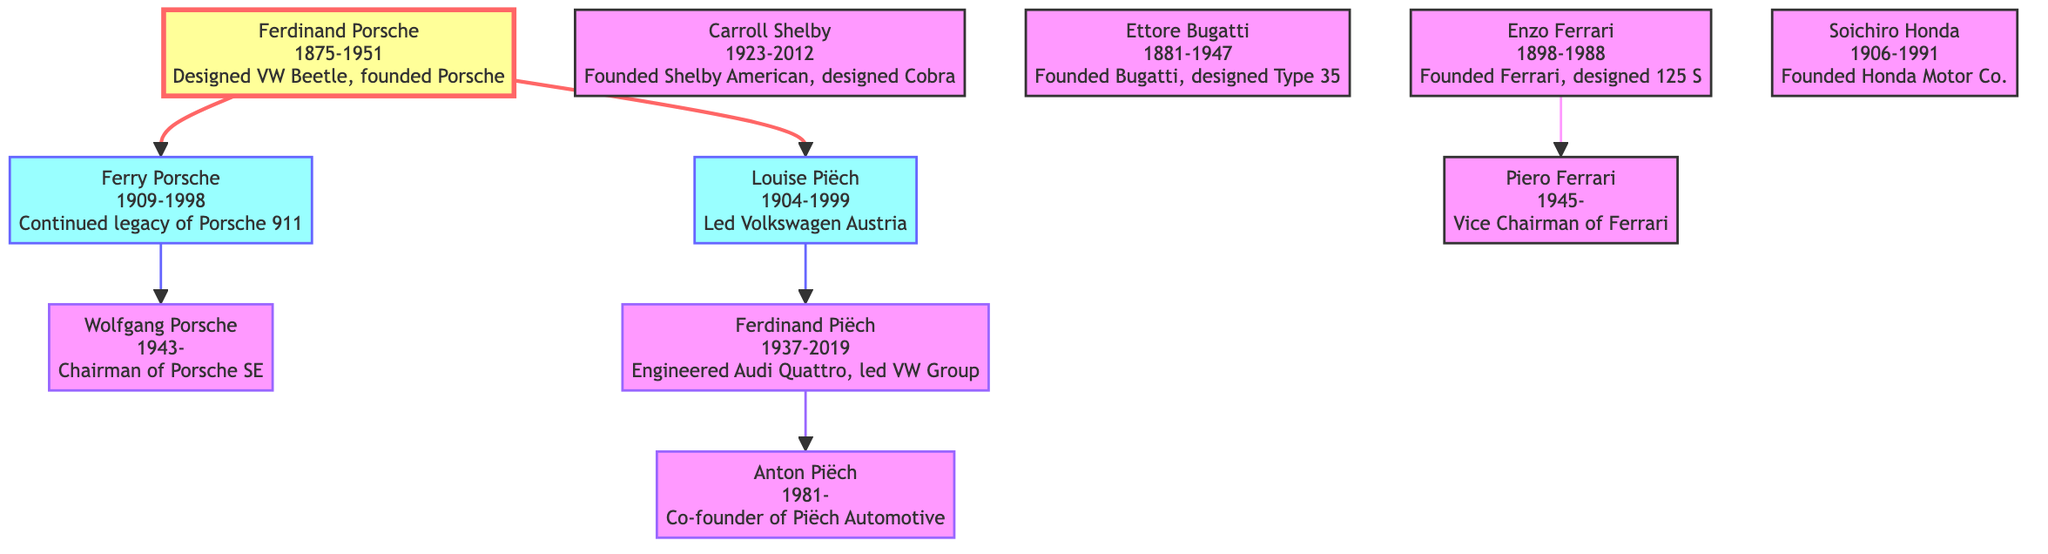What is the full name of the root node? The root node is the first element in the family tree, which in this case is Ferdinand Porsche.
Answer: Ferdinand Porsche How many children does Ferdinand Porsche have? Ferdinand Porsche has two children displayed in the diagram: Ferry Porsche and Louise Piëch.
Answer: 2 What year was Louise Piëch born? The birth year is found in her description as part of the family tree. Louise Piëch's birth year is 1904.
Answer: 1904 Who is the parent of Wolfgang Porsche? Wolfgang Porsche is a child of Ferry Porsche, as illustrated in the family lineage.
Answer: Ferry Porsche What is the key contribution of Ferdinand Piëch? Ferdinand Piëch's key contribution, as noted in the diagram, was engineering the Audi Quattro and leading the VW Group.
Answer: Engineered Audi Quattro, led VW Group How is Anton Piëch related to Ferdinand Piëch? Anton Piëch is a grandchild of Ferdinand Piëch, as he is a child of Ferdinand Piëch in the family lineage.
Answer: Grandchild Who are the two key figures directly under Enzo Ferrari? The key figure directly under Enzo Ferrari is his son, Piero Ferrari, while Enzo Ferrari himself is the founder of Ferrari.
Answer: Piero Ferrari What notable company did Carroll Shelby found? The diagram specifies that Carroll Shelby founded Shelby American, providing direct insight into his key contribution.
Answer: Shelby American How many generations does the family tree describe? The tree spans three generations: Ferdinand Porsche, his children (Ferry Porsche and Louise Piëch), and their descendants.
Answer: 3 